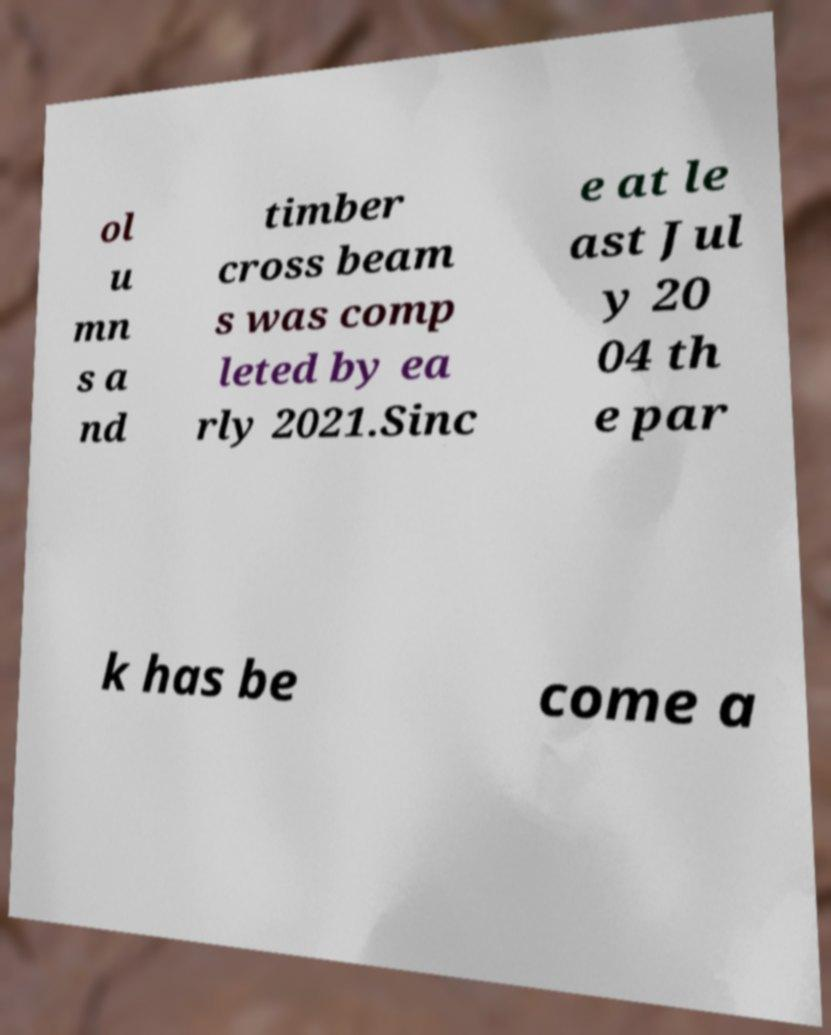Please read and relay the text visible in this image. What does it say? ol u mn s a nd timber cross beam s was comp leted by ea rly 2021.Sinc e at le ast Jul y 20 04 th e par k has be come a 